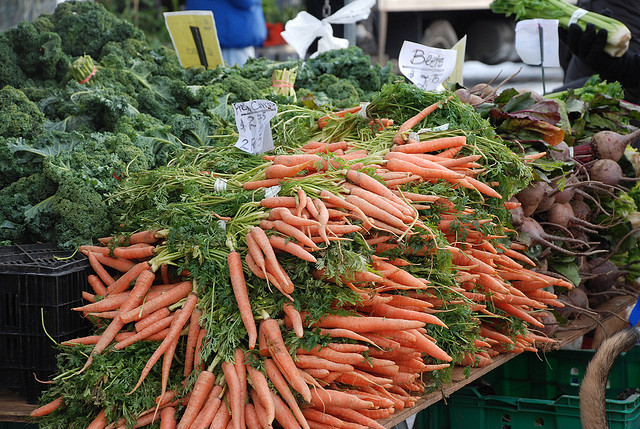<image>How does the dog food taste? I don't know how the dog food tastes. What kind of fruit is in this scene? There is no fruit in the image. However, it can be seen a carrot. How does the dog food taste? I don't know how the dog food tastes. What kind of fruit is in this scene? I am not sure what kind of fruit is in the scene. There is no fruit visible in the image. 